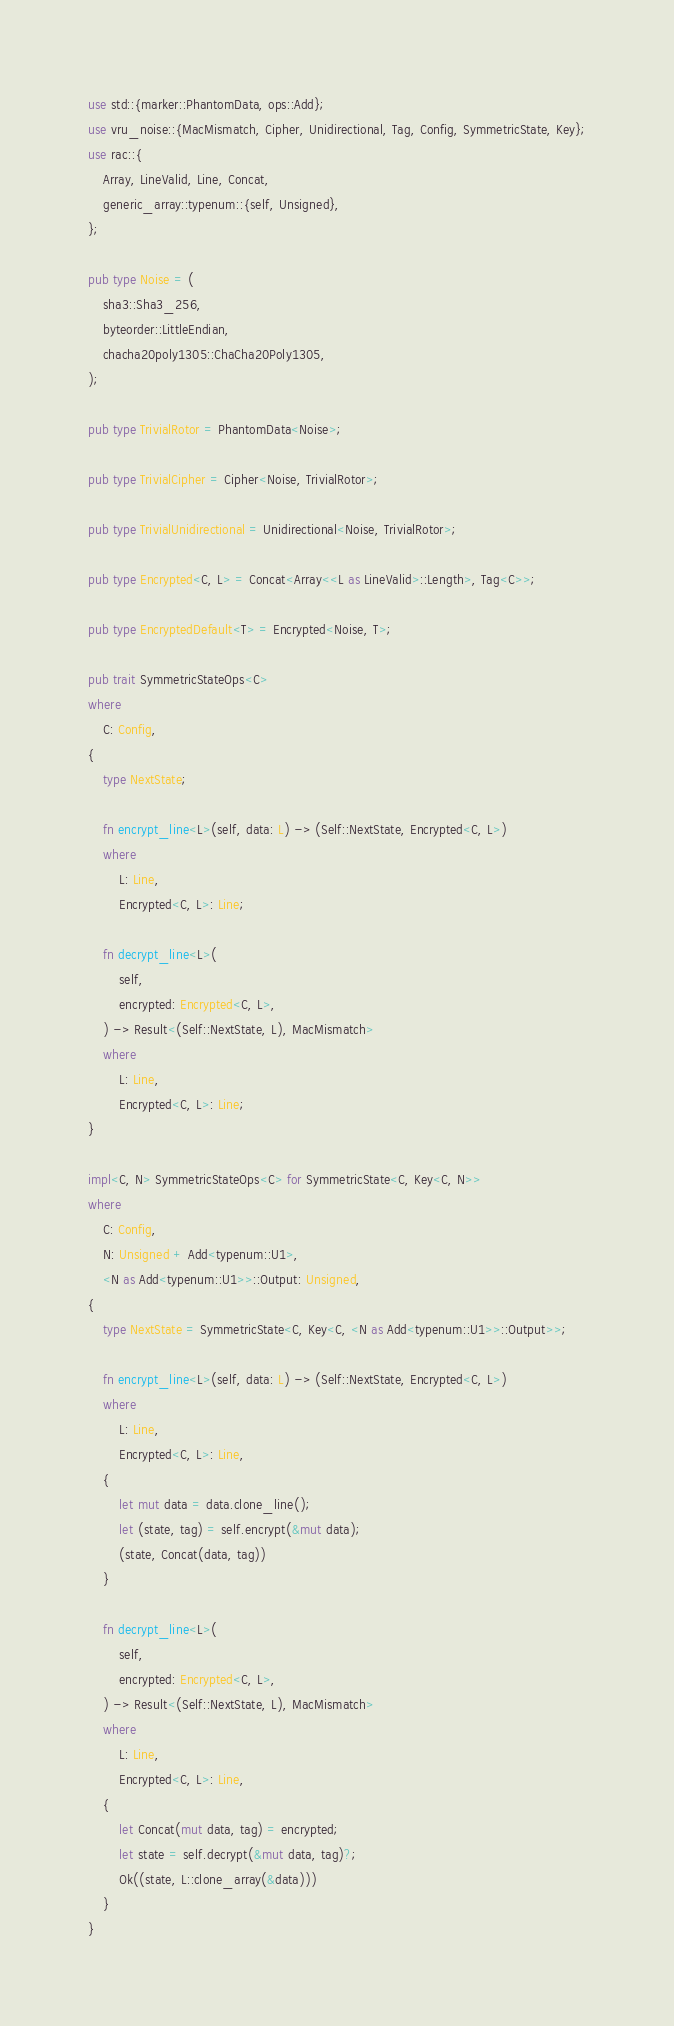Convert code to text. <code><loc_0><loc_0><loc_500><loc_500><_Rust_>use std::{marker::PhantomData, ops::Add};
use vru_noise::{MacMismatch, Cipher, Unidirectional, Tag, Config, SymmetricState, Key};
use rac::{
    Array, LineValid, Line, Concat,
    generic_array::typenum::{self, Unsigned},
};

pub type Noise = (
    sha3::Sha3_256,
    byteorder::LittleEndian,
    chacha20poly1305::ChaCha20Poly1305,
);

pub type TrivialRotor = PhantomData<Noise>;

pub type TrivialCipher = Cipher<Noise, TrivialRotor>;

pub type TrivialUnidirectional = Unidirectional<Noise, TrivialRotor>;

pub type Encrypted<C, L> = Concat<Array<<L as LineValid>::Length>, Tag<C>>;

pub type EncryptedDefault<T> = Encrypted<Noise, T>;

pub trait SymmetricStateOps<C>
where
    C: Config,
{
    type NextState;

    fn encrypt_line<L>(self, data: L) -> (Self::NextState, Encrypted<C, L>)
    where
        L: Line,
        Encrypted<C, L>: Line;

    fn decrypt_line<L>(
        self,
        encrypted: Encrypted<C, L>,
    ) -> Result<(Self::NextState, L), MacMismatch>
    where
        L: Line,
        Encrypted<C, L>: Line;
}

impl<C, N> SymmetricStateOps<C> for SymmetricState<C, Key<C, N>>
where
    C: Config,
    N: Unsigned + Add<typenum::U1>,
    <N as Add<typenum::U1>>::Output: Unsigned,
{
    type NextState = SymmetricState<C, Key<C, <N as Add<typenum::U1>>::Output>>;

    fn encrypt_line<L>(self, data: L) -> (Self::NextState, Encrypted<C, L>)
    where
        L: Line,
        Encrypted<C, L>: Line,
    {
        let mut data = data.clone_line();
        let (state, tag) = self.encrypt(&mut data);
        (state, Concat(data, tag))
    }

    fn decrypt_line<L>(
        self,
        encrypted: Encrypted<C, L>,
    ) -> Result<(Self::NextState, L), MacMismatch>
    where
        L: Line,
        Encrypted<C, L>: Line,
    {
        let Concat(mut data, tag) = encrypted;
        let state = self.decrypt(&mut data, tag)?;
        Ok((state, L::clone_array(&data)))
    }
}
</code> 